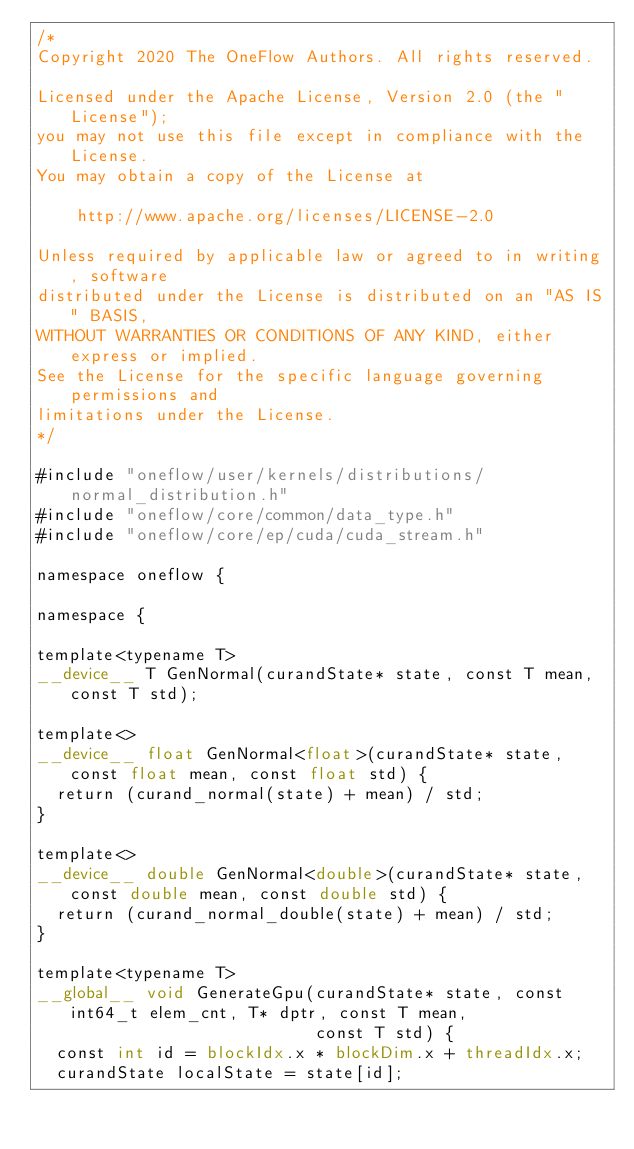<code> <loc_0><loc_0><loc_500><loc_500><_Cuda_>/*
Copyright 2020 The OneFlow Authors. All rights reserved.

Licensed under the Apache License, Version 2.0 (the "License");
you may not use this file except in compliance with the License.
You may obtain a copy of the License at

    http://www.apache.org/licenses/LICENSE-2.0

Unless required by applicable law or agreed to in writing, software
distributed under the License is distributed on an "AS IS" BASIS,
WITHOUT WARRANTIES OR CONDITIONS OF ANY KIND, either express or implied.
See the License for the specific language governing permissions and
limitations under the License.
*/

#include "oneflow/user/kernels/distributions/normal_distribution.h"
#include "oneflow/core/common/data_type.h"
#include "oneflow/core/ep/cuda/cuda_stream.h"

namespace oneflow {

namespace {

template<typename T>
__device__ T GenNormal(curandState* state, const T mean, const T std);

template<>
__device__ float GenNormal<float>(curandState* state, const float mean, const float std) {
  return (curand_normal(state) + mean) / std;
}

template<>
__device__ double GenNormal<double>(curandState* state, const double mean, const double std) {
  return (curand_normal_double(state) + mean) / std;
}

template<typename T>
__global__ void GenerateGpu(curandState* state, const int64_t elem_cnt, T* dptr, const T mean,
                            const T std) {
  const int id = blockIdx.x * blockDim.x + threadIdx.x;
  curandState localState = state[id];</code> 